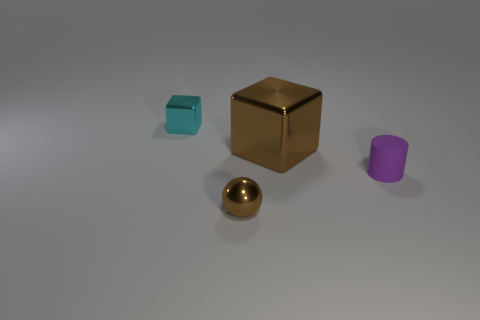Are there any tiny purple rubber things of the same shape as the big metallic object?
Keep it short and to the point. No. What number of objects are either things right of the small cyan cube or small gray metal spheres?
Ensure brevity in your answer.  3. Are there more tiny shiny objects than tiny purple rubber things?
Your response must be concise. Yes. Is there a green matte cylinder of the same size as the rubber thing?
Ensure brevity in your answer.  No. What number of things are brown shiny balls in front of the purple rubber cylinder or brown shiny spheres in front of the small purple matte cylinder?
Your answer should be very brief. 1. There is a thing in front of the purple cylinder that is right of the big brown shiny block; what is its color?
Provide a short and direct response. Brown. There is a tiny sphere that is made of the same material as the cyan block; what color is it?
Offer a very short reply. Brown. What number of big metallic objects have the same color as the cylinder?
Keep it short and to the point. 0. How many objects are either small red matte spheres or big metal objects?
Your answer should be compact. 1. There is a brown shiny object that is the same size as the purple thing; what shape is it?
Offer a terse response. Sphere. 